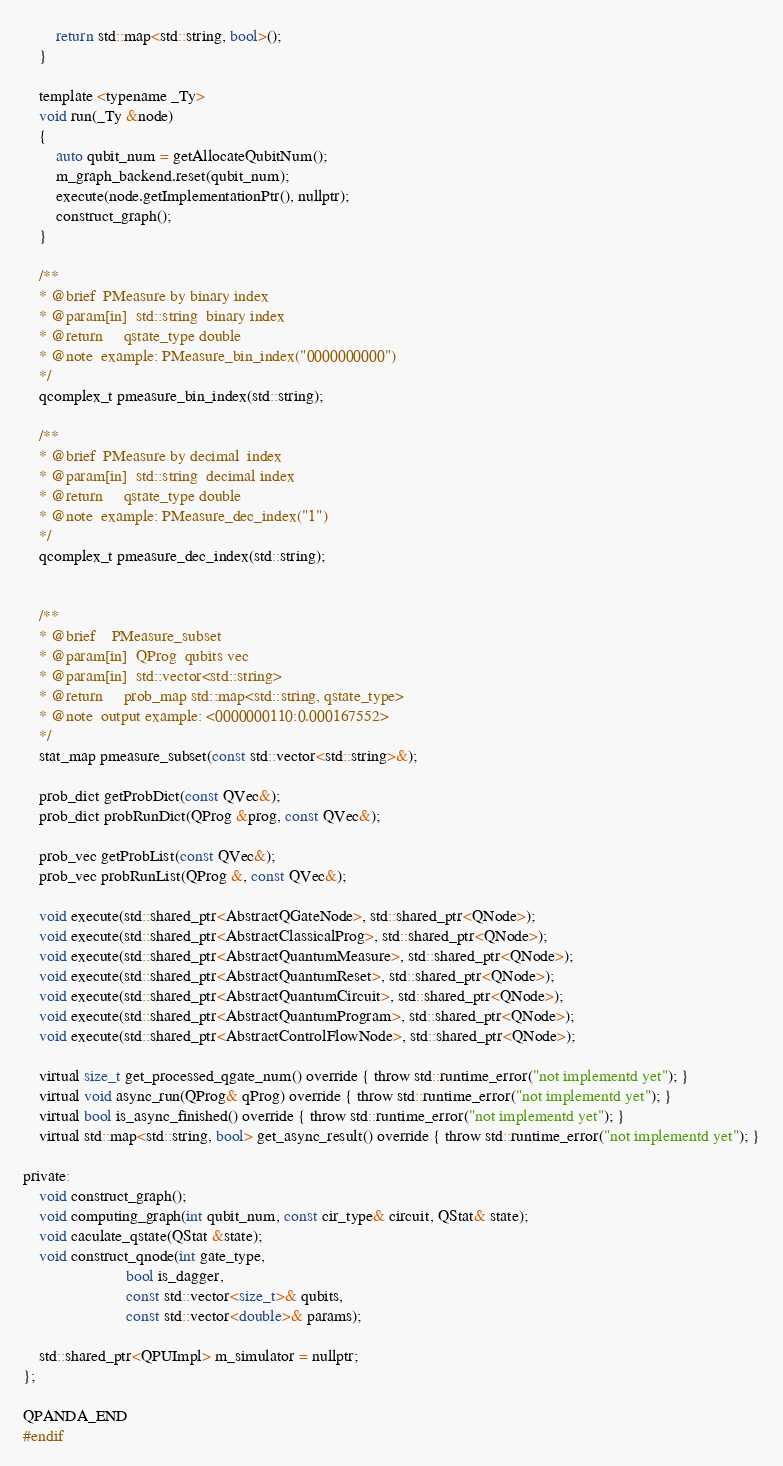Convert code to text. <code><loc_0><loc_0><loc_500><loc_500><_C_>        return std::map<std::string, bool>();
    }

	template <typename _Ty>
	void run(_Ty &node)
	{
		auto qubit_num = getAllocateQubitNum();
		m_graph_backend.reset(qubit_num);
		execute(node.getImplementationPtr(), nullptr);
		construct_graph();
	}

	/**
	* @brief  PMeasure by binary index
	* @param[in]  std::string  binary index
	* @return     qstate_type double
	* @note  example: PMeasure_bin_index("0000000000")
	*/
	qcomplex_t pmeasure_bin_index(std::string);

	/**
	* @brief  PMeasure by decimal  index
	* @param[in]  std::string  decimal index
	* @return     qstate_type double
	* @note  example: PMeasure_dec_index("1")
	*/
	qcomplex_t pmeasure_dec_index(std::string);


    /**
    * @brief    PMeasure_subset
    * @param[in]  QProg  qubits vec
    * @param[in]  std::vector<std::string>
    * @return     prob_map std::map<std::string, qstate_type>
    * @note  output example: <0000000110:0.000167552>
    */
	stat_map pmeasure_subset(const std::vector<std::string>&);

    prob_dict getProbDict(const QVec&);
    prob_dict probRunDict(QProg &prog, const QVec&);

    prob_vec getProbList(const QVec&);
    prob_vec probRunList(QProg &, const QVec&);

    void execute(std::shared_ptr<AbstractQGateNode>, std::shared_ptr<QNode>);
    void execute(std::shared_ptr<AbstractClassicalProg>, std::shared_ptr<QNode>);
    void execute(std::shared_ptr<AbstractQuantumMeasure>, std::shared_ptr<QNode>);
	void execute(std::shared_ptr<AbstractQuantumReset>, std::shared_ptr<QNode>);
    void execute(std::shared_ptr<AbstractQuantumCircuit>, std::shared_ptr<QNode>);
    void execute(std::shared_ptr<AbstractQuantumProgram>, std::shared_ptr<QNode>);
    void execute(std::shared_ptr<AbstractControlFlowNode>, std::shared_ptr<QNode>);

    virtual size_t get_processed_qgate_num() override { throw std::runtime_error("not implementd yet"); }
	virtual void async_run(QProg& qProg) override { throw std::runtime_error("not implementd yet"); }
	virtual bool is_async_finished() override { throw std::runtime_error("not implementd yet"); }
    virtual std::map<std::string, bool> get_async_result() override { throw std::runtime_error("not implementd yet"); }

private:
	void construct_graph();
	void computing_graph(int qubit_num, const cir_type& circuit, QStat& state);
    void caculate_qstate(QStat &state);
    void construct_qnode(int gate_type,
                         bool is_dagger,
                         const std::vector<size_t>& qubits,
                         const std::vector<double>& params);

    std::shared_ptr<QPUImpl> m_simulator = nullptr;
};

QPANDA_END
#endif

</code> 